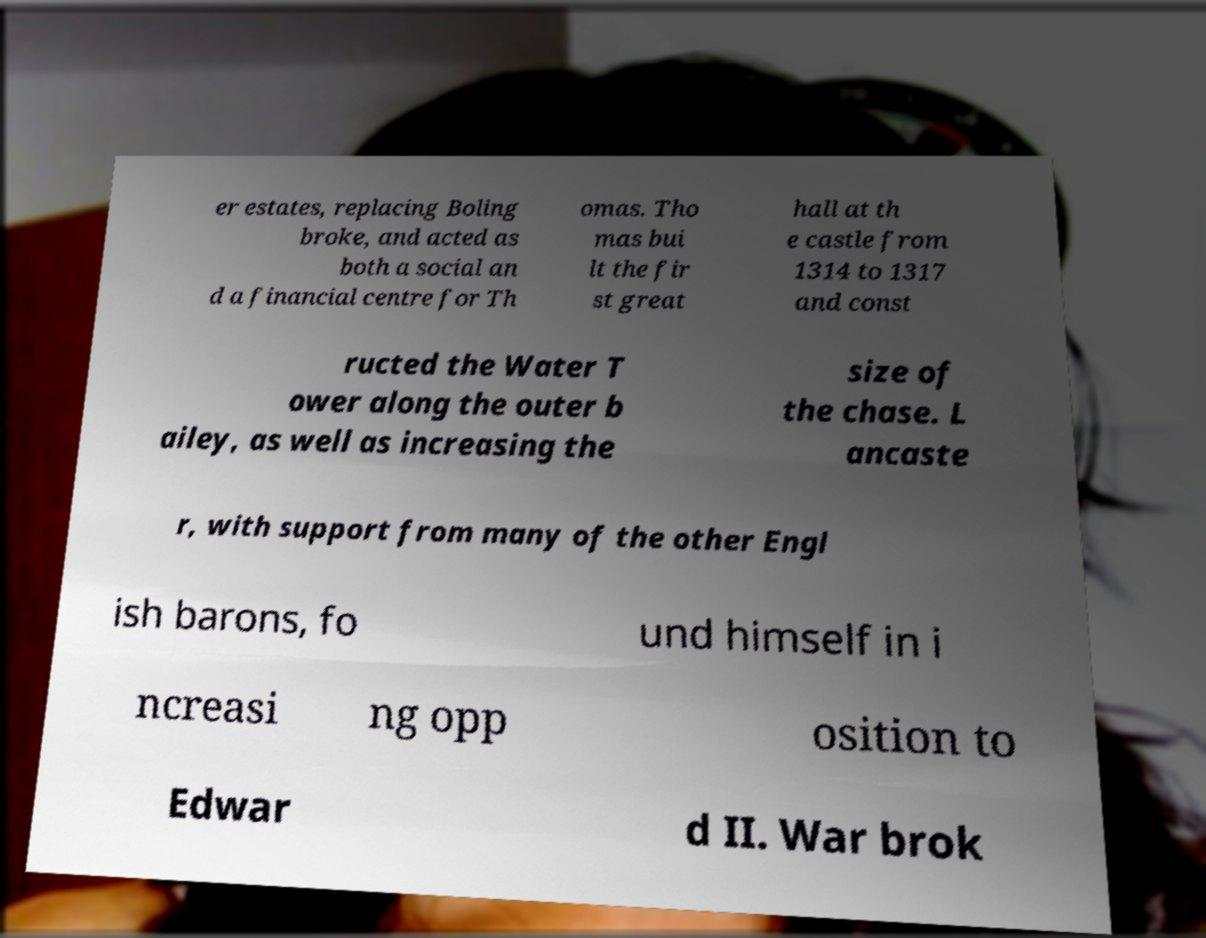Please read and relay the text visible in this image. What does it say? er estates, replacing Boling broke, and acted as both a social an d a financial centre for Th omas. Tho mas bui lt the fir st great hall at th e castle from 1314 to 1317 and const ructed the Water T ower along the outer b ailey, as well as increasing the size of the chase. L ancaste r, with support from many of the other Engl ish barons, fo und himself in i ncreasi ng opp osition to Edwar d II. War brok 